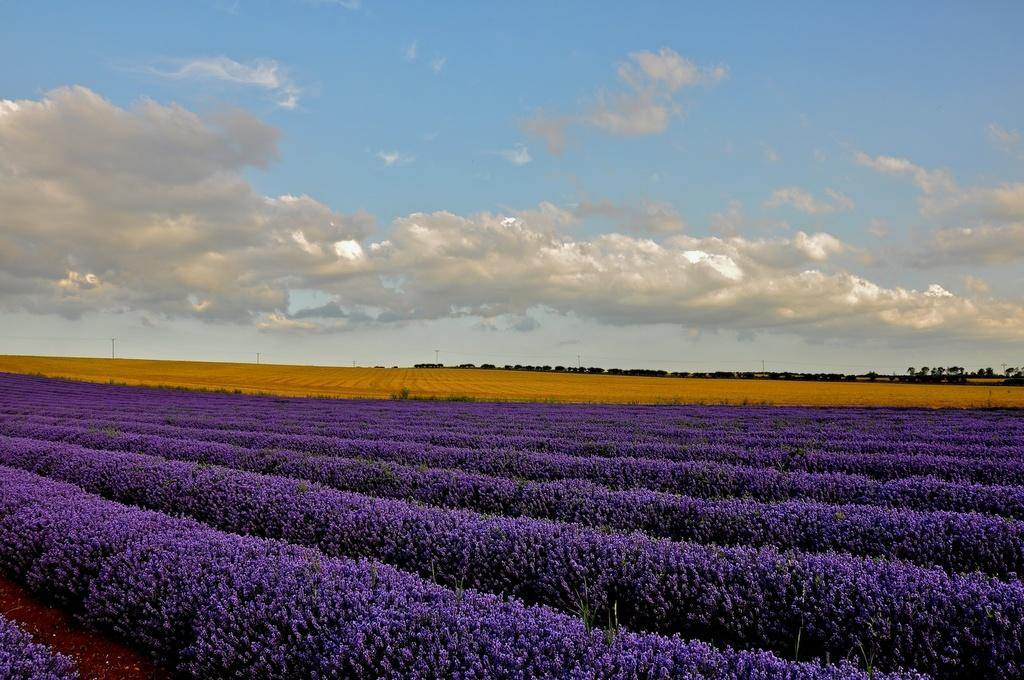What type of plants are present in the image? There are plants with flowers in the image. What can be seen in the background of the image? There is a group of trees and poles visible in the background of the image. What is visible at the top of the image? The sky is visible in the background of the image. What type of cemetery can be seen in the image? There is no cemetery present in the image. How many people are gripping the edge of the image? There are no people present in the image, so no one is gripping the edge. 